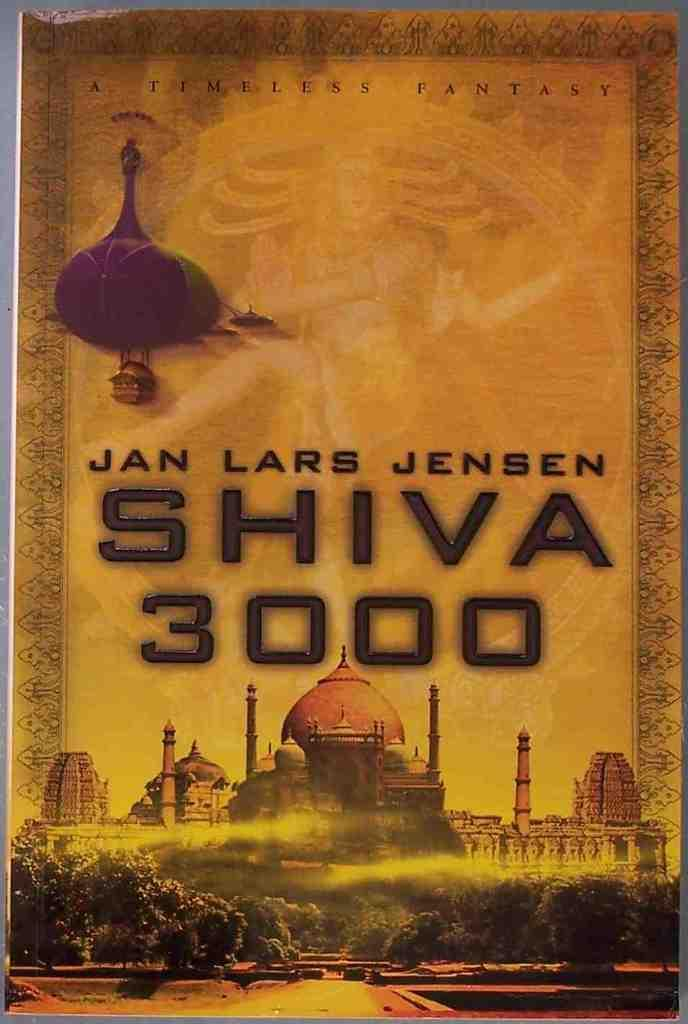What is the main subject of the image? The main subject of the image is a poster. What can be found on the poster? The poster contains depictions and some information. Can you see the thumb of the artist who created the poster in the image? There is no thumb visible in the image; it is a picture of a poster. What type of paper is the poster made of in the image? The type of paper the poster is made of cannot be determined from the image. 